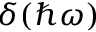Convert formula to latex. <formula><loc_0><loc_0><loc_500><loc_500>\delta ( \hbar { \omega } )</formula> 